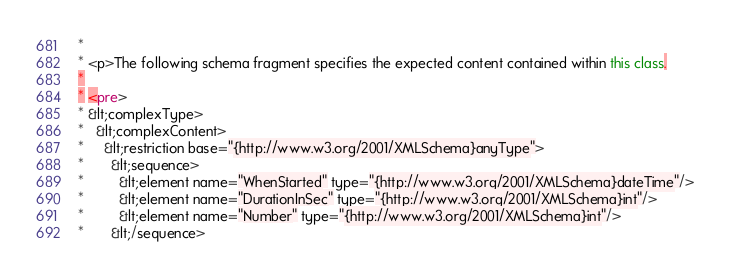Convert code to text. <code><loc_0><loc_0><loc_500><loc_500><_Java_> * 
 * <p>The following schema fragment specifies the expected content contained within this class.
 * 
 * <pre>
 * &lt;complexType>
 *   &lt;complexContent>
 *     &lt;restriction base="{http://www.w3.org/2001/XMLSchema}anyType">
 *       &lt;sequence>
 *         &lt;element name="WhenStarted" type="{http://www.w3.org/2001/XMLSchema}dateTime"/>
 *         &lt;element name="DurationInSec" type="{http://www.w3.org/2001/XMLSchema}int"/>
 *         &lt;element name="Number" type="{http://www.w3.org/2001/XMLSchema}int"/>
 *       &lt;/sequence></code> 